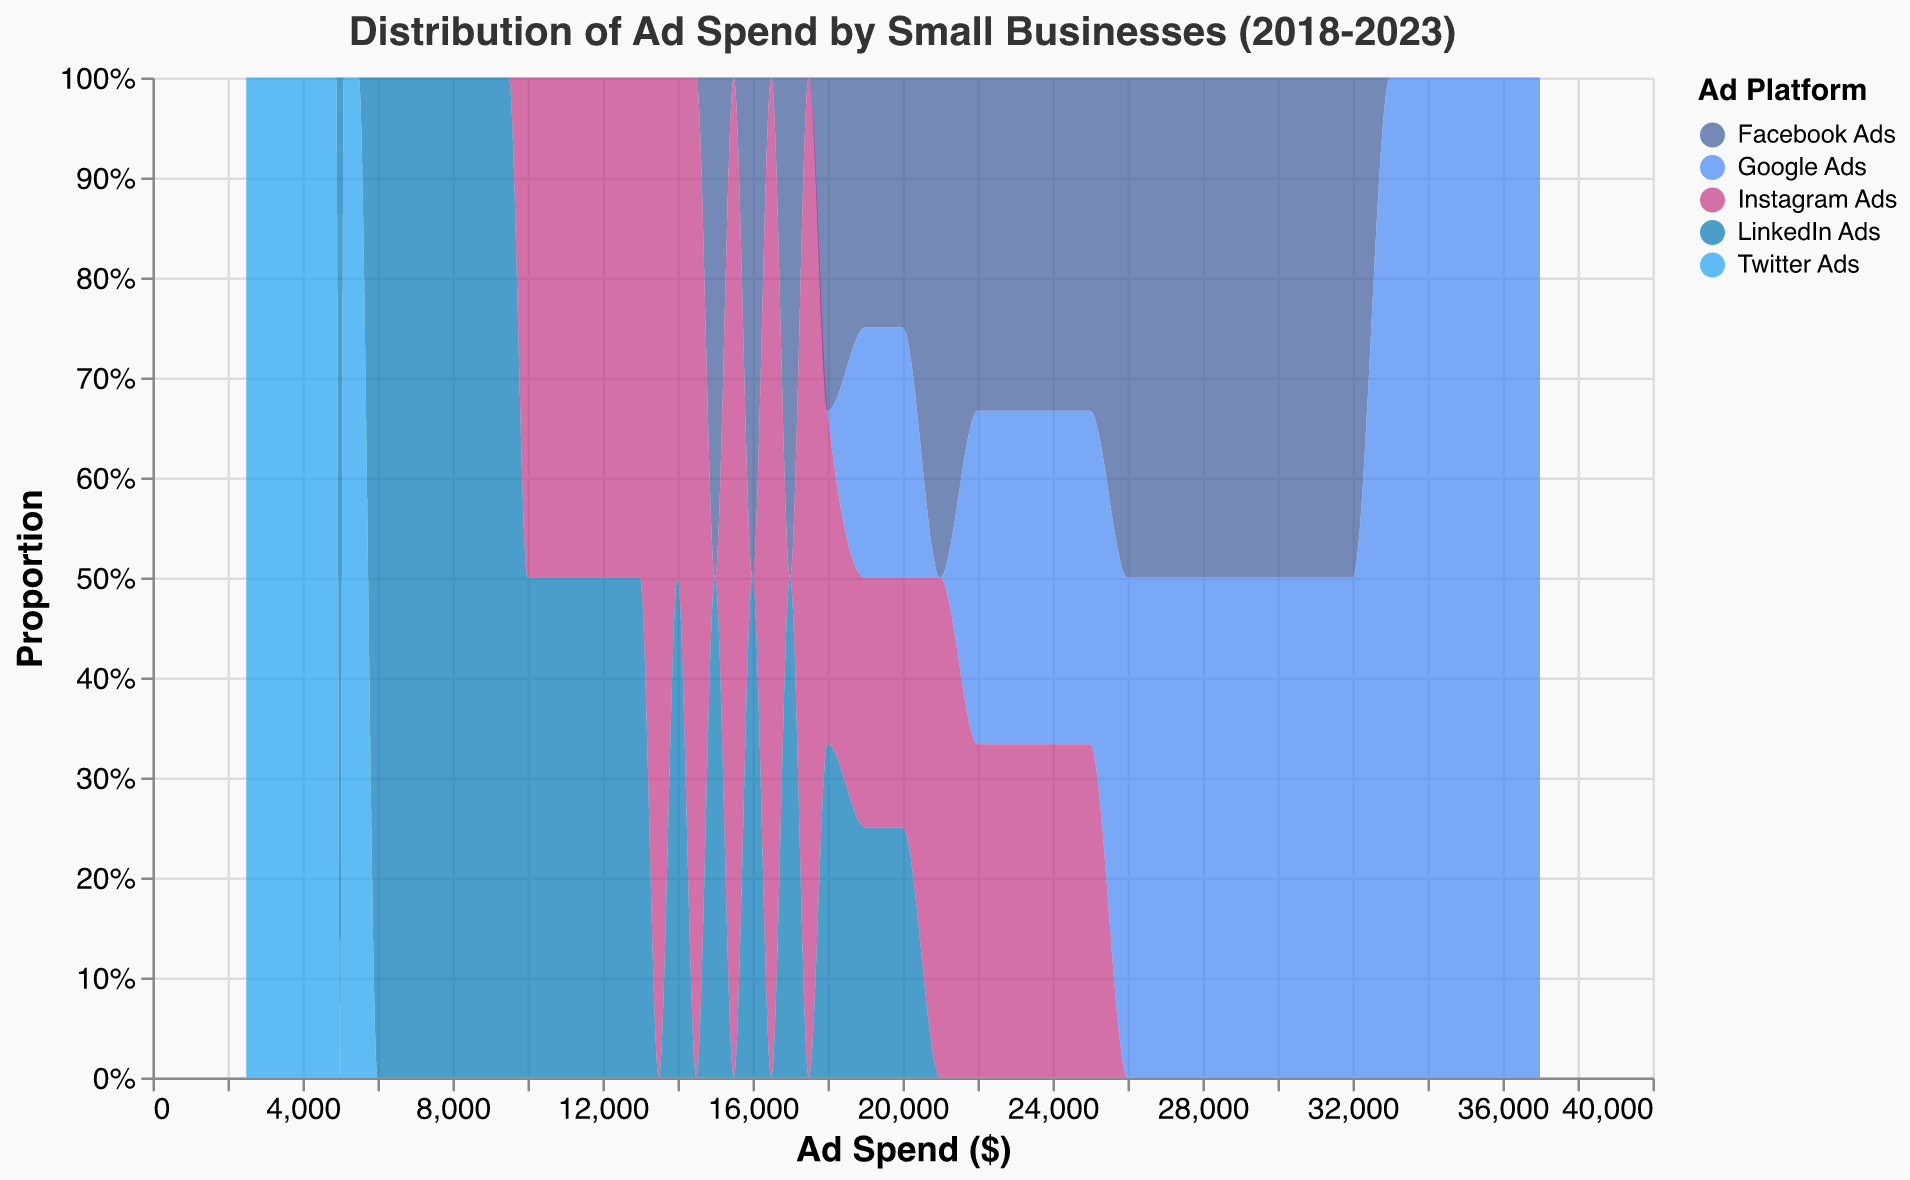What is the title of the plot? The title is displayed at the top of the plot, typically in a larger and bold font for visibility. Here, the title is "Distribution of Ad Spend by Small Businesses (2018-2023)."
Answer: Distribution of Ad Spend by Small Businesses (2018-2023) How is the x-axis labeled? The x-axis is labeled to show what each point on this axis represents. In this plot, the x-axis is labeled "Ad Spend ($)," indicating it represents the amount of money spent on ads.
Answer: Ad Spend ($) Which ad platform is represented by the color blue? In the legend on the right side of the plot, each color corresponds to a specific ad platform. The color blue is associated with "Google Ads."
Answer: Google Ads Which platform has the least amount of ad spend across all years? The heights and proportions of the density areas give an idea of the overall distribution. "Twitter Ads" has the smallest proportion, indicating the least ad spend.
Answer: Twitter Ads Which year shows the highest ad spend for Facebook Ads? By observing the distribution trends over the years related to Facebook Ads, the data shows the highest ad spend in 2023.
Answer: 2023 What is the general trend in ad spend for LinkedIn Ads over the years? The plot shows the overlap and movement of the density areas over time. LinkedIn Ads show a steady increase in ad spend from 2018 to 2023.
Answer: Increasing trend Which ad platform's spending shows the greatest increase from 2018 to 2023? By comparing the positions and spreads of the areas at 2018 and 2023, Google Ads shows the most significant increase in ad spend over the period.
Answer: Google Ads How does the ad spend distribution for Instagram Ads in 2020 compare to that in 2022? By examining the spreads and peaks of the density areas for Instagram Ads in 2020 and 2022, it's evident that the distribution shifts to higher values, indicating an increase in ad spend.
Answer: Increased in 2022 Approximately, what is the range of ad spend for Twitter Ads from 2018 to 2023? The x-axis values where the density area exists for Twitter Ads shows that the range is from about $2500 to $5500.
Answer: $2500 to $5500 Which ad platform has the most consistent spending over the years? Stability can be inferred from the uniformity in the spread and peak positions over the years. LinkedIn Ads have a steady and consistent increase over the years.
Answer: LinkedIn Ads 